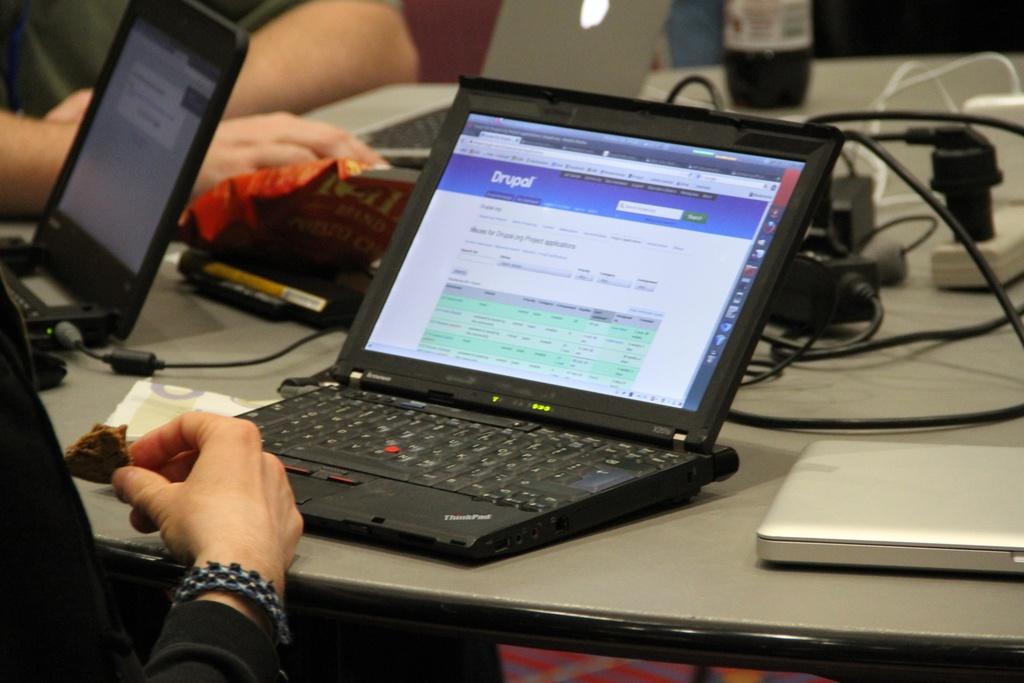What website is that?
Your response must be concise. Drupal. 